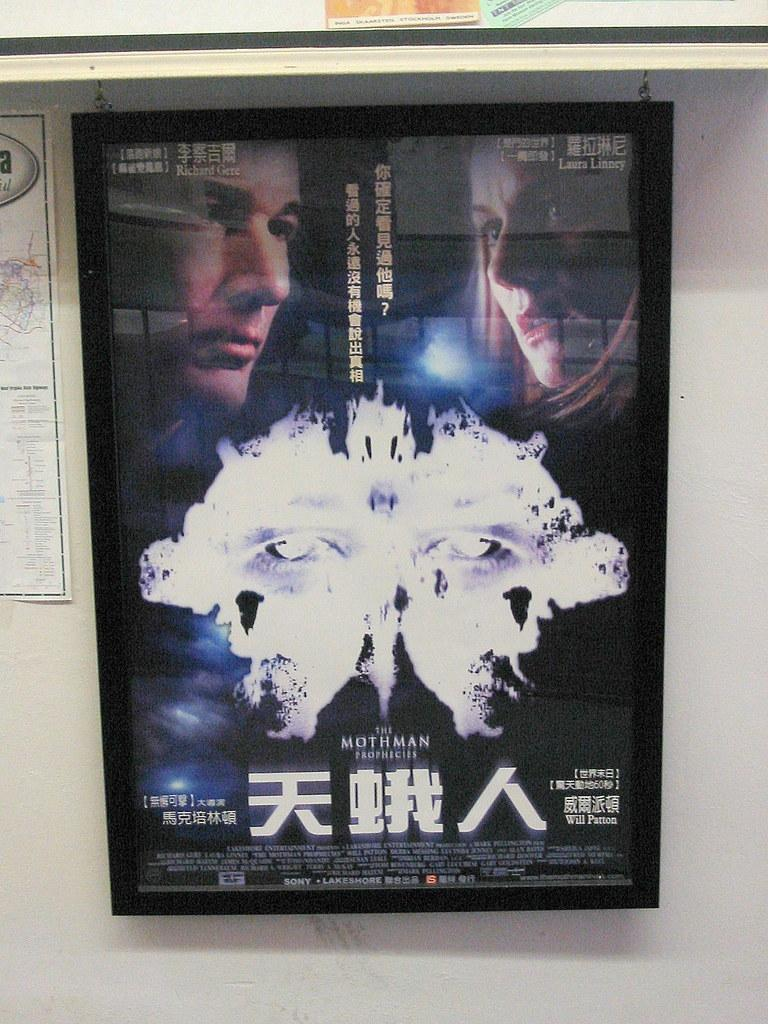<image>
Render a clear and concise summary of the photo. the word mothman is on the sign on the wall 